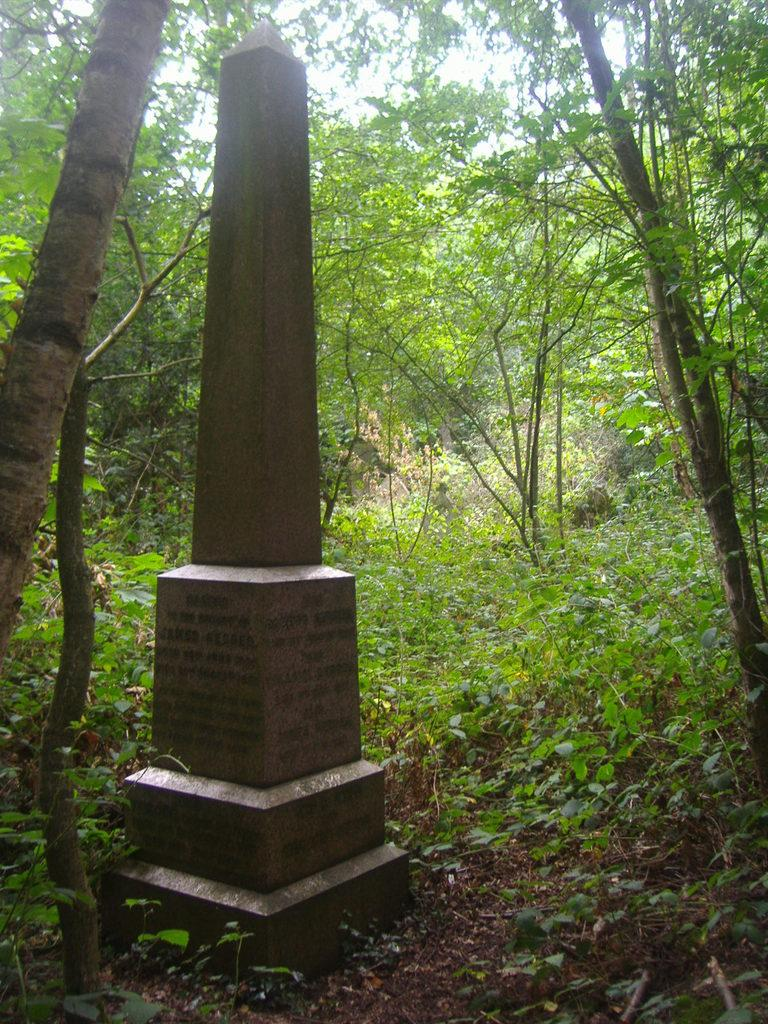What is the main structure in the image? There is a stone pillar in the image. Where is the stone pillar located? The stone pillar is in the middle of a forest. What can be seen in the background of the image? There are many trees and plants in the background of the image. What is the price of the hat in the image? There is no hat present in the image, so there is no price to determine. 